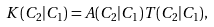Convert formula to latex. <formula><loc_0><loc_0><loc_500><loc_500>K ( C _ { 2 } | C _ { 1 } ) = A ( C _ { 2 } | C _ { 1 } ) T ( C _ { 2 } | C _ { 1 } ) ,</formula> 